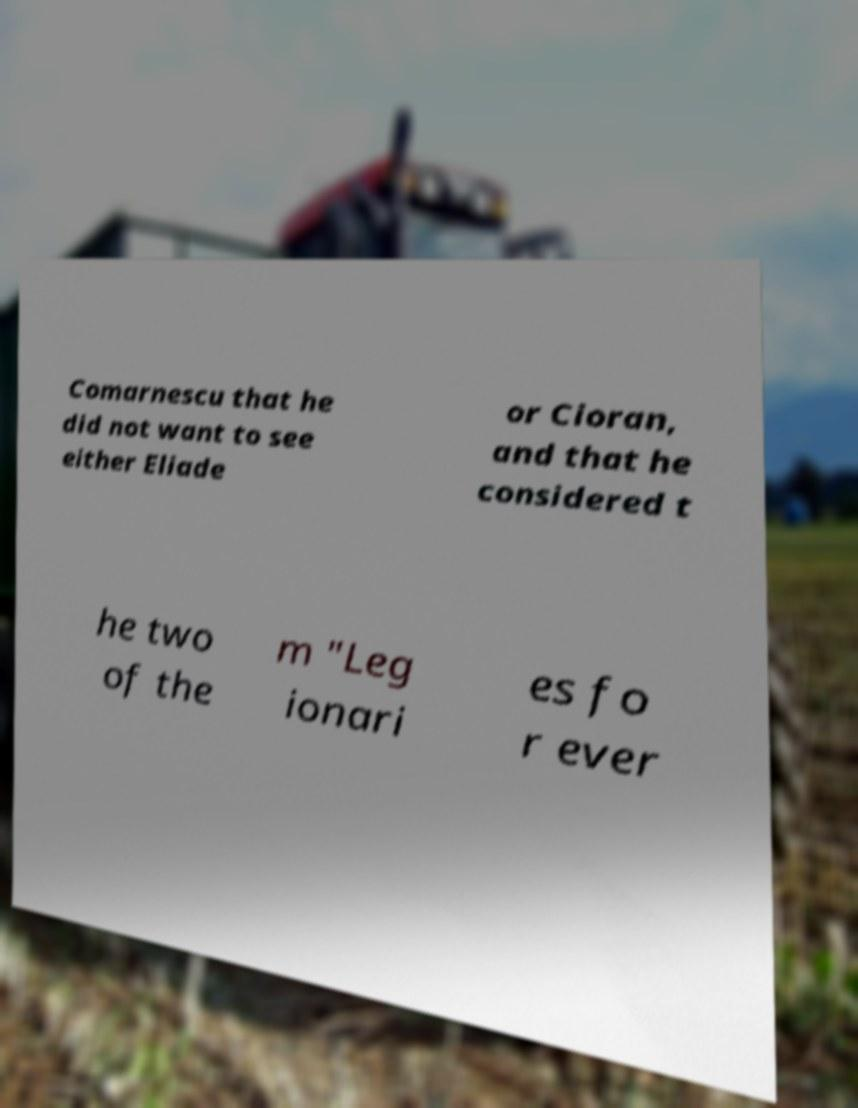Can you read and provide the text displayed in the image?This photo seems to have some interesting text. Can you extract and type it out for me? Comarnescu that he did not want to see either Eliade or Cioran, and that he considered t he two of the m "Leg ionari es fo r ever 